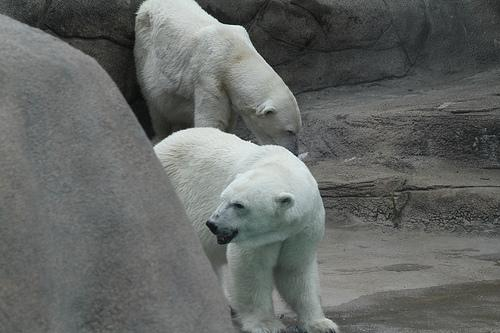What is the distinct feature of the bear's body parts? The polar bear has a black nose, dark eyes, and a brown spot on its white fur. Examine the interaction between the bear and the rocks or water in the image. The polar bear has its foot partially submerged in water, and it appears to be close to big rocks and rock steps. What do you think is happening with the polar bear's mouth? The polar bear's mouth is open, perhaps it's making a sound, yawning or breathing heavily. What is the overall sentiment or mood the image conveys? The image conveys a natural and serene mood, showcasing the polar bear in its natural habitat among rocks and water. Can you describe the appearance of the bear in the image? The bear is a large white polar bear with a dark eye, a black nose, its mouth open, its head lowered and turned, and a brown spot on its fur. Identify the main colors present in the image. The main colors present in the image are white, black, gray, and also a bit of brown. Determine the number of rocks and steps present in the image, based on the information given. There are large gray rocks, a big boulder, a big rock between the polar bear, and steps made of rock, amounting to four different rock formations. Count the number of polar bears in the image and describe their positioning. There is one polar bear in the image, and it's near some large gray rocks with its foot in the water, surrounded by steps made of rock. Tell me about the setting and environment around the polar bear in the image. The polar bear is surrounded by large gray rocks and steps made of rock, with its foot partially in water, and a big boulder nearby. Give a brief analysis of the image quality based on the provided image. The image quality appears to be good, with detailed bounding boxes around the polar bear and the surrounding environment. 